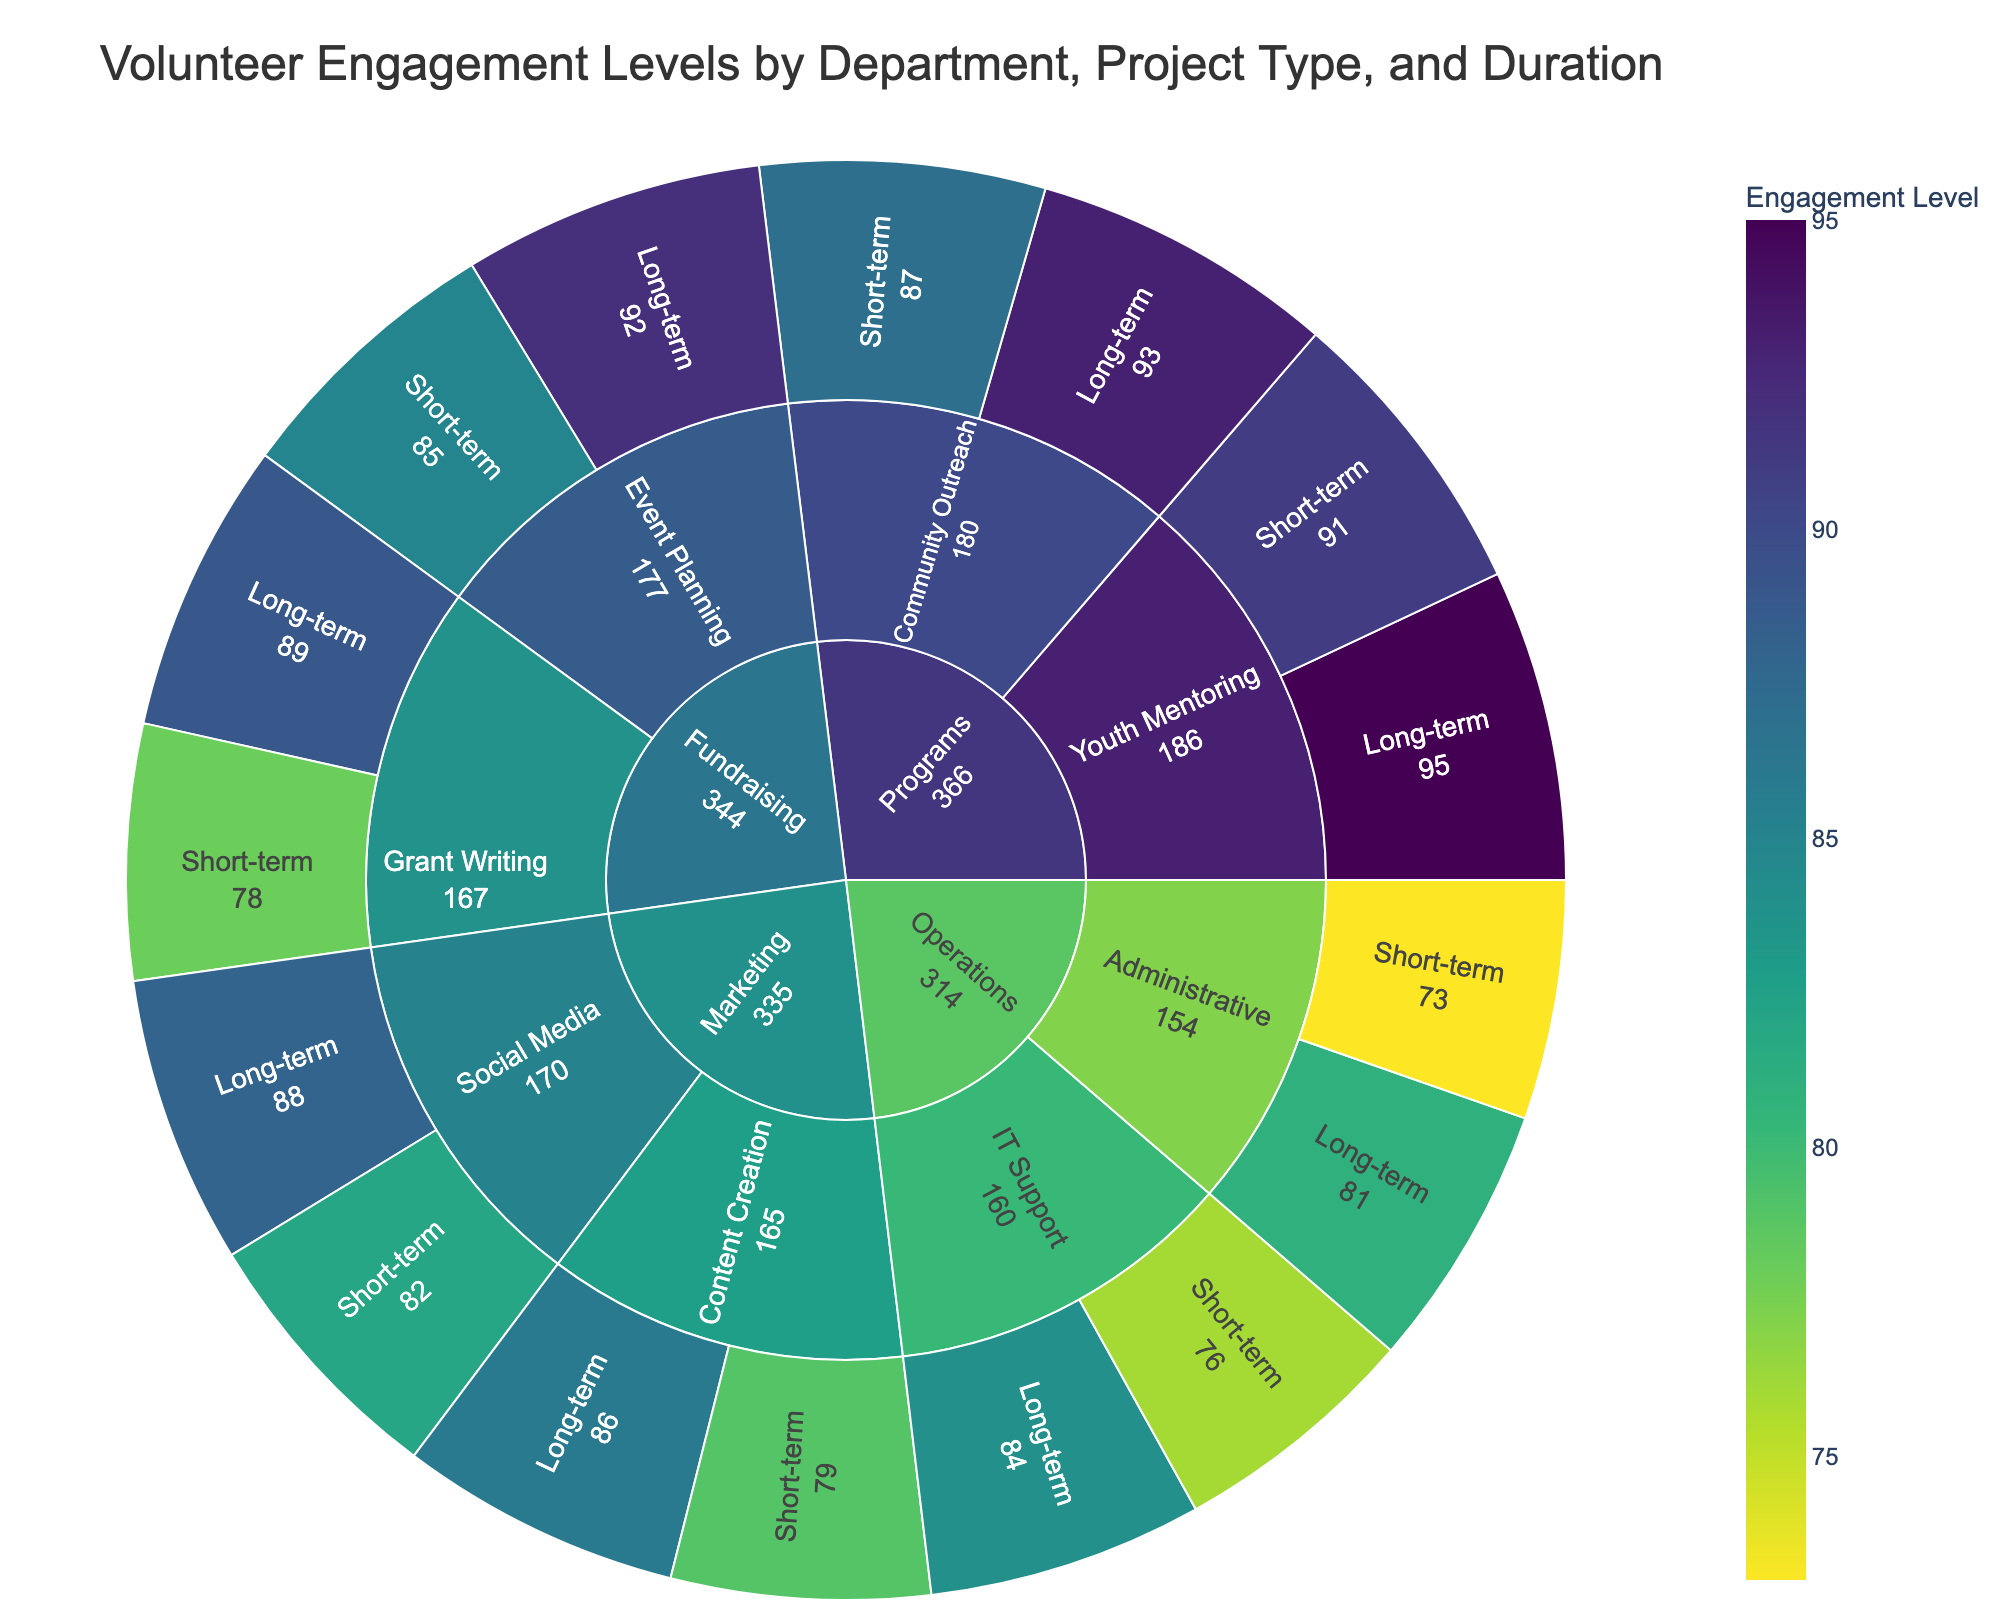What's the highest engagement level for Fundraising projects? To answer this, look at the segments under the Fundraising department and identify the one with the highest engagement level. The highest value in this section is 92.
Answer: 92 Which department has the highest average engagement level? Calculate the average engagement level for each department by summing the engagement levels and dividing by the number of projects. Programs: (91 + 95 + 87 + 93)/4 = 91.5; Fundraising: (85 + 92 + 78 + 89)/4 = 86; Marketing: (82 + 88 + 79 + 86)/4 = 83.75; Operations: (76 + 84 + 73 + 81)/4 = 78.5. So, Programs has the highest average engagement level of 91.5.
Answer: Programs What is the engagement level for long-term Community Outreach projects? Locate the Programs department, then find the Community Outreach project type. The segment for long-term Community Outreach projects shows an engagement level of 93.
Answer: 93 Which project type within the Marketing department has the lowest engagement level? Examine both project types (Social Media and Content Creation) and compare their segments. Social Media has 82 and 88, while Content Creation has 79 and 86. The lowest level is 79 for short-term Content Creation.
Answer: Content Creation (short-term) How does the engagement level for long-term Youth Mentoring compare to short-term Administrative tasks? First, find the engagement levels: 95 for long-term Youth Mentoring and 73 for short-term Administrative tasks. Comparing the two, long-term Youth Mentoring has a higher engagement level.
Answer: Long-term Youth Mentoring is higher What is the average engagement level for short-term projects in Operations? Add the engagement levels for short-term projects in Operations: IT Support (76) and Administrative (73). The total is 149, and since there are 2 projects, the average is 149/2 = 74.5.
Answer: 74.5 In terms of engagement levels, which shows more variance: short-term or long-term projects? Examine the engagement levels for both durations. Short-term ranges from 73 to 91, showing a variance of 18. Long-term ranges from 81 to 95, showing a variance of 14. Short-term projects have a wider range and thus more variance.
Answer: Short-term projects Looking at the Fundraising department, which has higher engagement levels, Event Planning or Grant Writing for long-term projects? Check the values for long-term projects: Event Planning has 92, and Grant Writing has 89. Event Planning has higher engagement levels.
Answer: Event Planning What is the total engagement level for all the projects in the Programs department? Sum up all the engagement levels for Programs: Youth Mentoring (91 + 95) and Community Outreach (87 + 93). The total is 91 + 95 + 87 + 93 = 366.
Answer: 366 